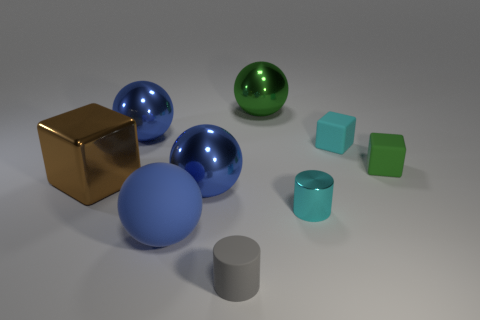There is a small rubber thing that is on the right side of the cyan matte cube; is it the same color as the big shiny ball to the right of the small gray rubber object?
Your answer should be compact. Yes. Is the number of green shiny things left of the gray matte thing less than the number of brown balls?
Provide a short and direct response. No. Do the small cyan object behind the tiny green thing and the green rubber object that is to the right of the large blue matte sphere have the same shape?
Keep it short and to the point. Yes. How many objects are large blue metallic objects that are on the right side of the large matte thing or gray matte cylinders?
Keep it short and to the point. 2. Are there any tiny rubber things that are behind the tiny gray matte object that is to the left of the big sphere that is to the right of the gray rubber cylinder?
Your response must be concise. Yes. Is the number of rubber things on the right side of the tiny green rubber cube less than the number of large spheres to the left of the large blue matte object?
Make the answer very short. Yes. There is a cylinder that is the same material as the large block; what color is it?
Keep it short and to the point. Cyan. There is a small cube behind the green rubber object that is right of the brown thing; what color is it?
Offer a very short reply. Cyan. Is there a metal object that has the same color as the big rubber ball?
Your response must be concise. Yes. What shape is the other cyan thing that is the same size as the cyan shiny object?
Provide a succinct answer. Cube. 